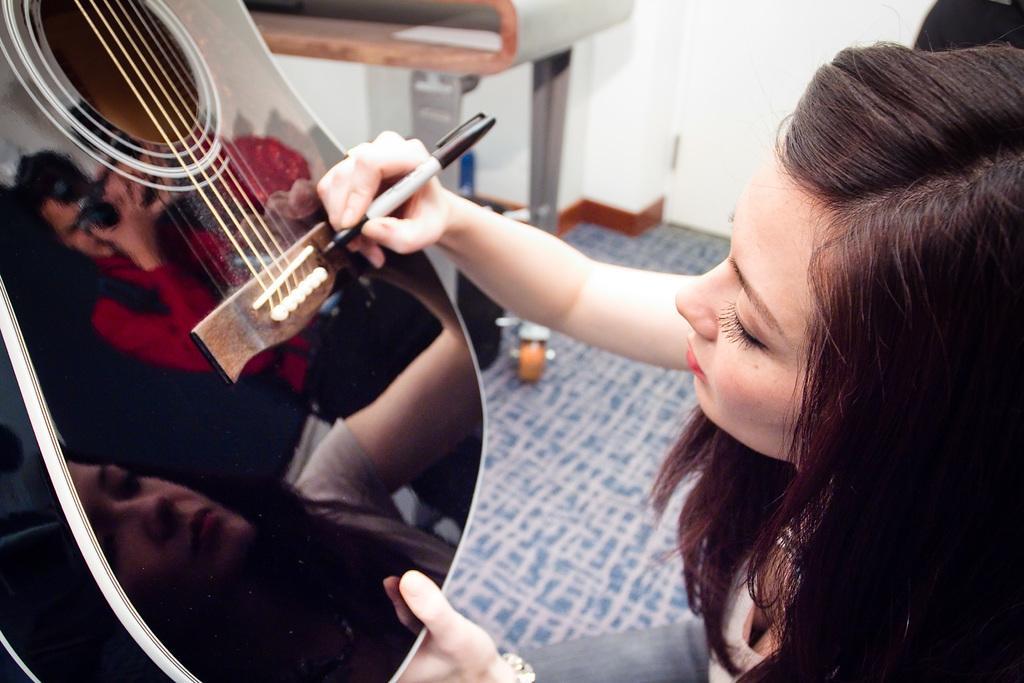Please provide a concise description of this image. The lady is writing something on a guitar. 